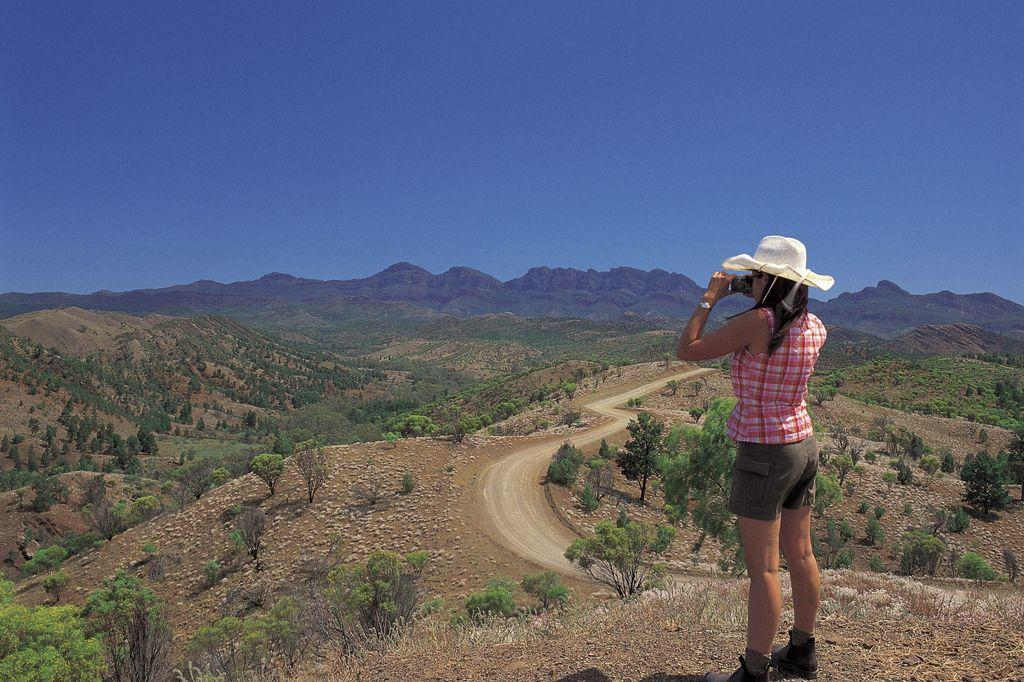Who is present in the image? There is a lady in the image. What is the lady wearing on her head? The lady is wearing a hat. What is the lady holding in her hand? The lady is holding something in her hand. What can be seen in the background of the image? There are trees, a road, hills, and the sky visible in the background of the image. What type of loaf is the lady feeding to the monkey in the image? There is no loaf or monkey present in the image. What adjustment does the lady need to make to her hat in the image? The lady is not making any adjustments to her hat in the image. 